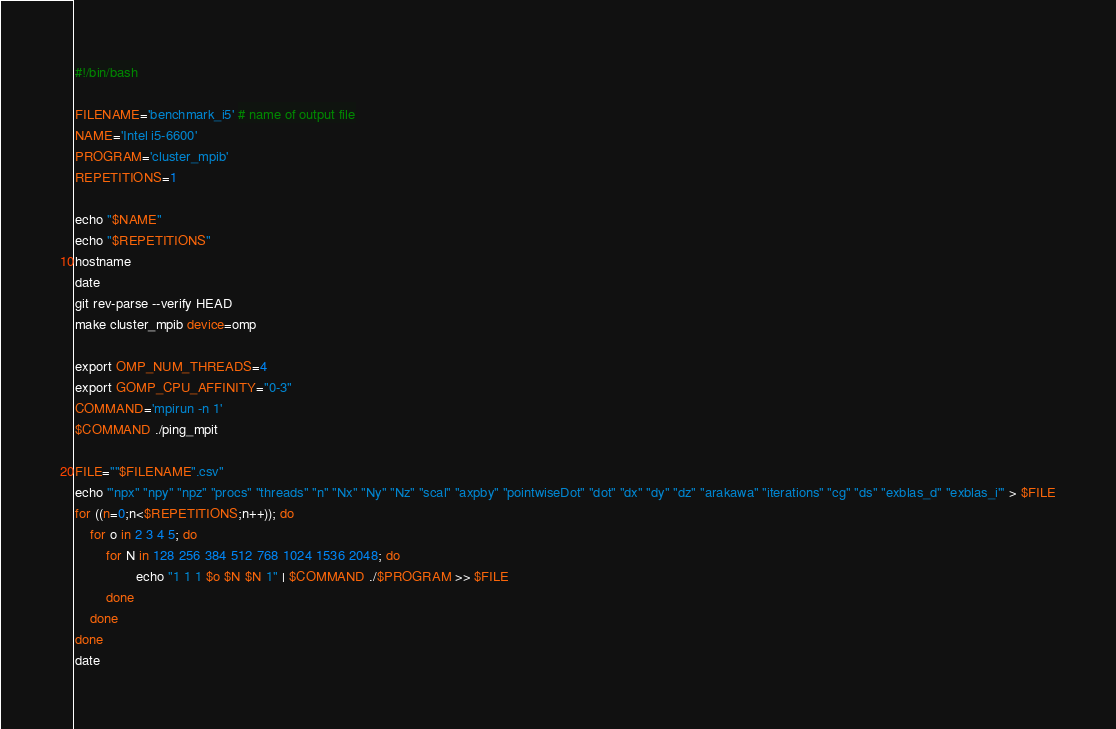Convert code to text. <code><loc_0><loc_0><loc_500><loc_500><_Bash_>#!/bin/bash

FILENAME='benchmark_i5' # name of output file
NAME='Intel i5-6600'
PROGRAM='cluster_mpib'
REPETITIONS=1

echo "$NAME"
echo "$REPETITIONS"
hostname 
date
git rev-parse --verify HEAD
make cluster_mpib device=omp

export OMP_NUM_THREADS=4
export GOMP_CPU_AFFINITY="0-3"
COMMAND='mpirun -n 1'
$COMMAND ./ping_mpit

FILE=""$FILENAME".csv"
echo '"npx" "npy" "npz" "procs" "threads" "n" "Nx" "Ny" "Nz" "scal" "axpby" "pointwiseDot" "dot" "dx" "dy" "dz" "arakawa" "iterations" "cg" "ds" "exblas_d" "exblas_i"' > $FILE
for ((n=0;n<$REPETITIONS;n++)); do
    for o in 2 3 4 5; do
        for N in 128 256 384 512 768 1024 1536 2048; do
                echo "1 1 1 $o $N $N 1" | $COMMAND ./$PROGRAM >> $FILE
        done
    done
done
date
</code> 